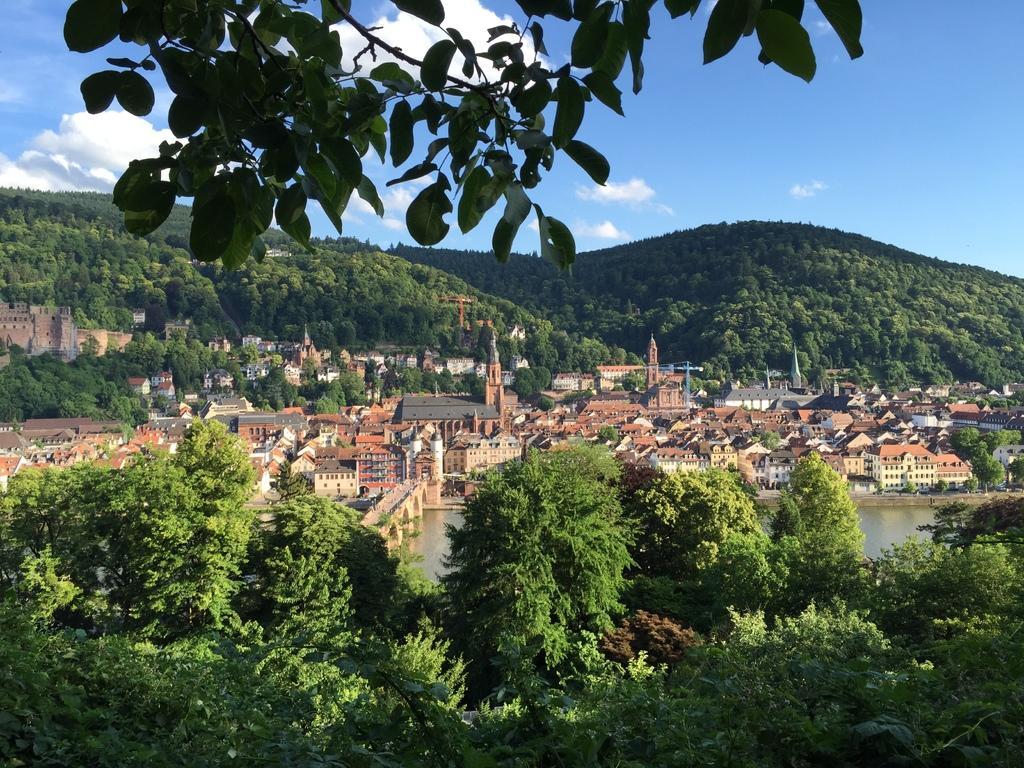How would you summarize this image in a sentence or two? In the center of the image there are buildings. At the bottom of the image there are trees. In the background of the image there are mountains and sky. 